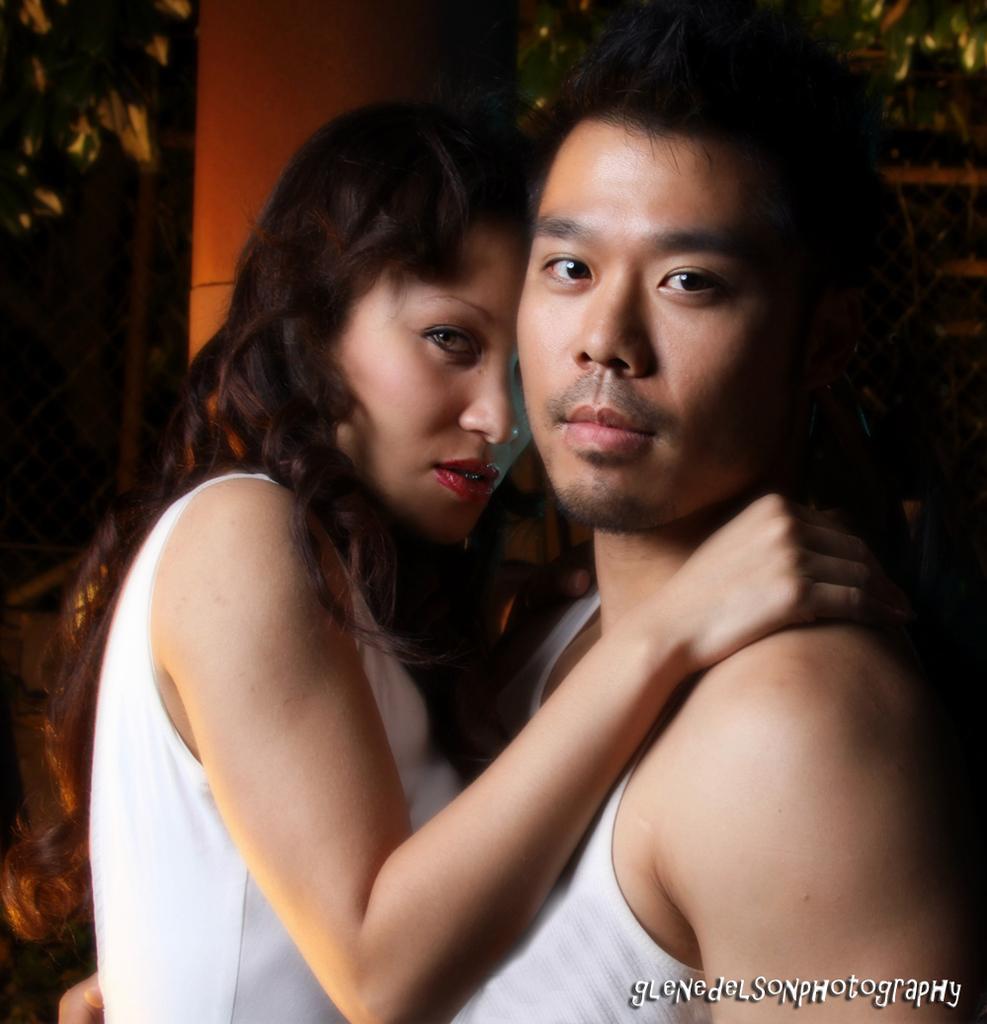Can you describe this image briefly? In this picture I can observe a couple. Both of them are wearing white color dresses. In the bottom right side I can observe watermark. 